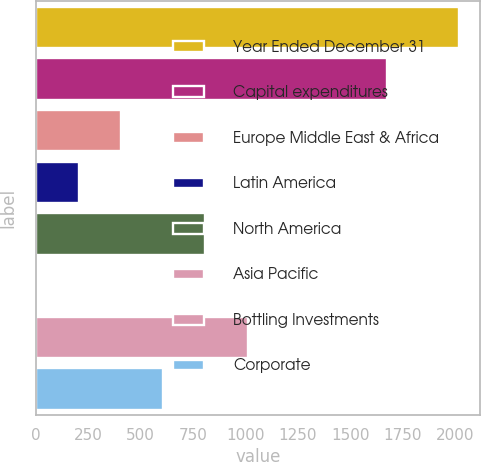<chart> <loc_0><loc_0><loc_500><loc_500><bar_chart><fcel>Year Ended December 31<fcel>Capital expenditures<fcel>Europe Middle East & Africa<fcel>Latin America<fcel>North America<fcel>Asia Pacific<fcel>Bottling Investments<fcel>Corporate<nl><fcel>2017<fcel>1675<fcel>405.8<fcel>204.4<fcel>808.6<fcel>3<fcel>1010<fcel>607.2<nl></chart> 